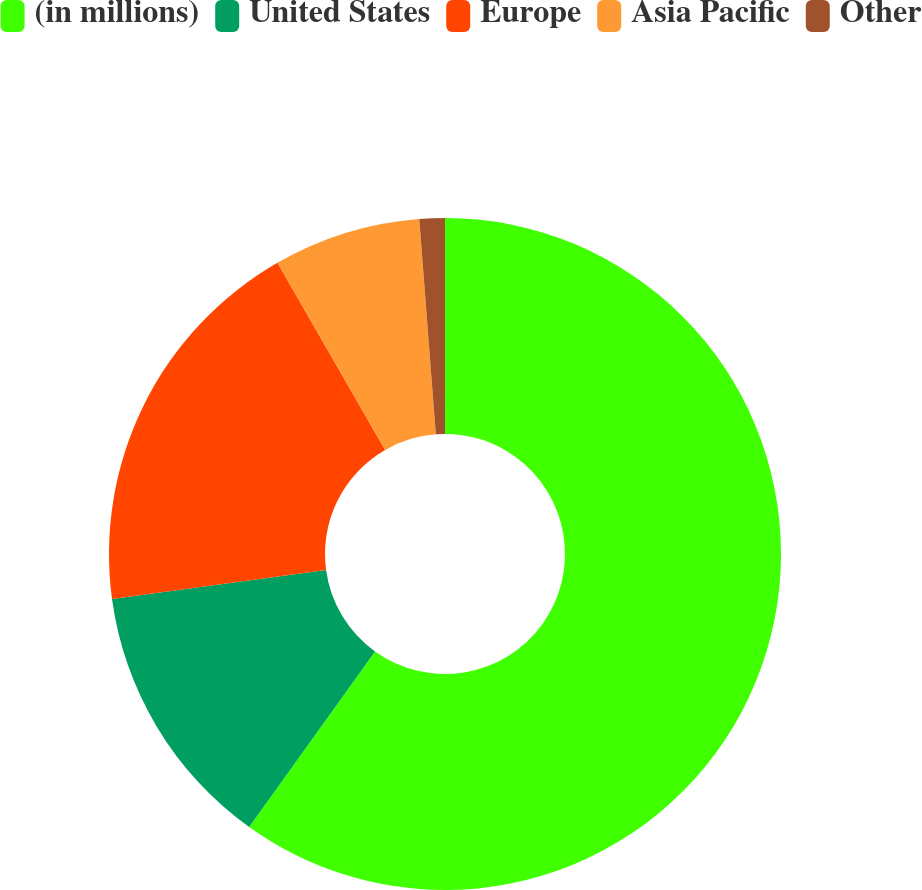<chart> <loc_0><loc_0><loc_500><loc_500><pie_chart><fcel>(in millions)<fcel>United States<fcel>Europe<fcel>Asia Pacific<fcel>Other<nl><fcel>59.91%<fcel>12.96%<fcel>18.83%<fcel>7.09%<fcel>1.22%<nl></chart> 